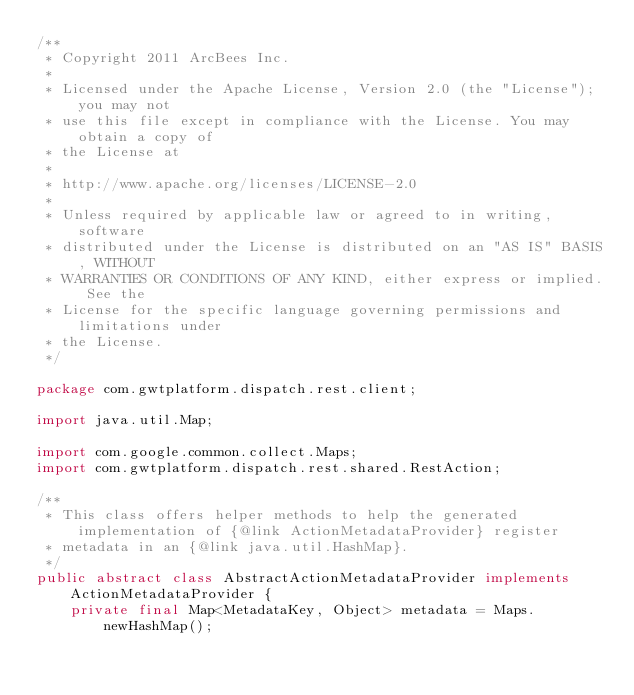Convert code to text. <code><loc_0><loc_0><loc_500><loc_500><_Java_>/**
 * Copyright 2011 ArcBees Inc.
 *
 * Licensed under the Apache License, Version 2.0 (the "License"); you may not
 * use this file except in compliance with the License. You may obtain a copy of
 * the License at
 *
 * http://www.apache.org/licenses/LICENSE-2.0
 *
 * Unless required by applicable law or agreed to in writing, software
 * distributed under the License is distributed on an "AS IS" BASIS, WITHOUT
 * WARRANTIES OR CONDITIONS OF ANY KIND, either express or implied. See the
 * License for the specific language governing permissions and limitations under
 * the License.
 */

package com.gwtplatform.dispatch.rest.client;

import java.util.Map;

import com.google.common.collect.Maps;
import com.gwtplatform.dispatch.rest.shared.RestAction;

/**
 * This class offers helper methods to help the generated implementation of {@link ActionMetadataProvider} register
 * metadata in an {@link java.util.HashMap}.
 */
public abstract class AbstractActionMetadataProvider implements ActionMetadataProvider {
    private final Map<MetadataKey, Object> metadata = Maps.newHashMap();
</code> 